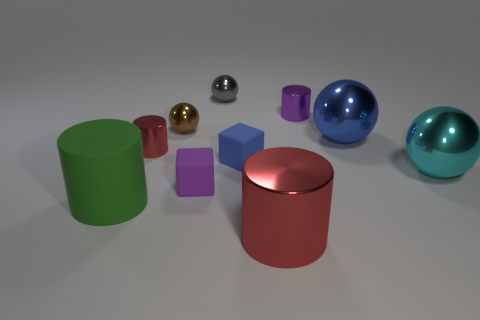Subtract all large cyan spheres. How many spheres are left? 3 Add 7 big shiny objects. How many big shiny objects are left? 10 Add 9 brown shiny balls. How many brown shiny balls exist? 10 Subtract all blue spheres. How many spheres are left? 3 Subtract 0 blue cylinders. How many objects are left? 10 Subtract all cubes. How many objects are left? 8 Subtract 2 cylinders. How many cylinders are left? 2 Subtract all brown balls. Subtract all blue blocks. How many balls are left? 3 Subtract all yellow balls. How many cyan cubes are left? 0 Subtract all large cyan rubber spheres. Subtract all blue cubes. How many objects are left? 9 